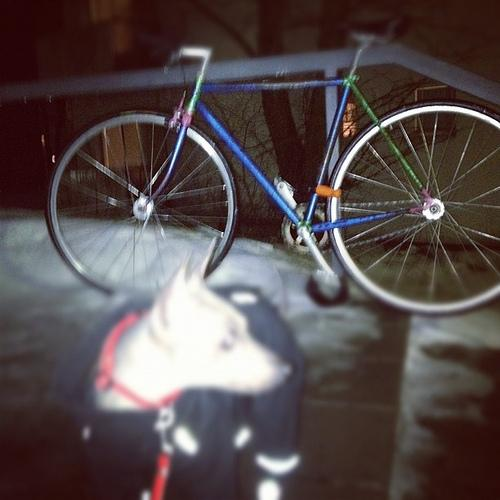Briefly describe the situation presented in the image. The image displays a white dog in a black outfit near a blue bicycle on a snowy day, with the dog looking in the right direction. Illustrate the main subjects and their surroundings in the image. A white dog with red collar and black outfit is standing next to a blue bicycle with silver details, parked on a snowy sidewalk by a metal rail. Summarize the scene depicted in the image. The image shows a white dog in a black outfit and a red leash next to a blue bicycle on a snowy sidewalk with lit windows in the background. Outline the main components of the image and any interesting details. The main components are a white dog, a blue bicycle, and a snowy environment; the dog's red collar and leash, and bicycle's silver parts are also noticeable. Provide a brief description of the primary focus of the image. A small white dog wearing a red collar and a black outfit is standing near a blue bicycle parked on a snowy sidewalk. Identify the primary and secondary figures in this photograph and their surroundings. The primary figure is a white dog wearing a black outfit and red collar, whereas the secondary figure is a blue bicycle; they are situated on a snowy sidewalk. Describe the key colors and objects featured in the image. The image highlights a blue and green bicycle, red collar and leash on a white dog in a black outfit, and silver bicycle components on a snowy day. Portray the main elements and setting found within the image. A white dog in a black outfit with red collar and leash stands beside a blue bicycle on a snowy pavement near a silver metal porch rail. Mention the most noticeable elements in the image. A white dog dressed in dark attire, blue bicycle with front and rear tires, red collar and leash, and a snow-covered cement porch. Discuss the primary subject and any secondary subjects in the image. A small white dog dressed in black is the main subject, accompanied by a blue bicycle, a red collar and leash, and a snowy sidewalk as secondary subjects. 